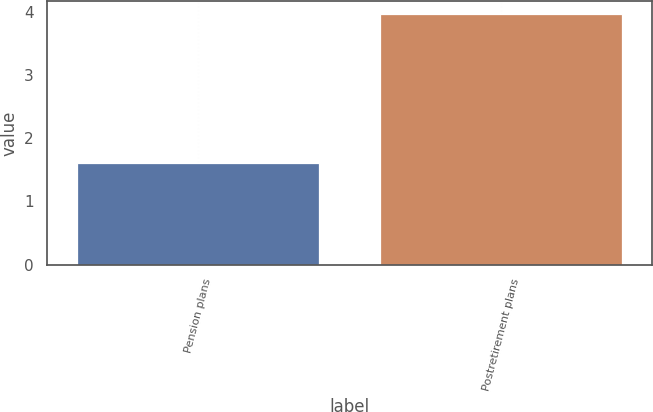Convert chart. <chart><loc_0><loc_0><loc_500><loc_500><bar_chart><fcel>Pension plans<fcel>Postretirement plans<nl><fcel>1.61<fcel>3.97<nl></chart> 